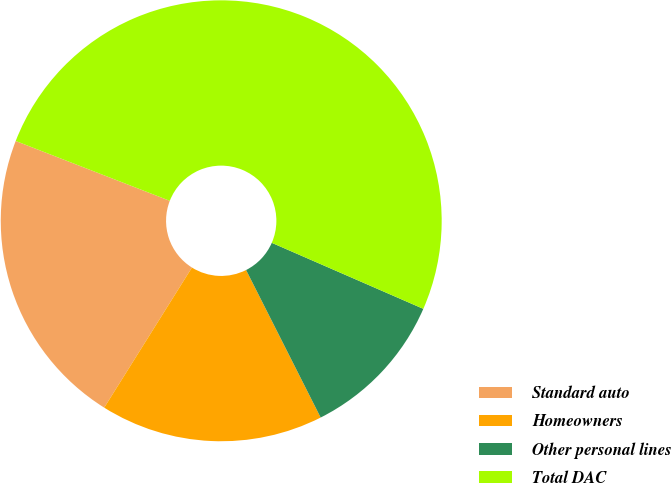<chart> <loc_0><loc_0><loc_500><loc_500><pie_chart><fcel>Standard auto<fcel>Homeowners<fcel>Other personal lines<fcel>Total DAC<nl><fcel>21.99%<fcel>16.35%<fcel>11.01%<fcel>50.64%<nl></chart> 